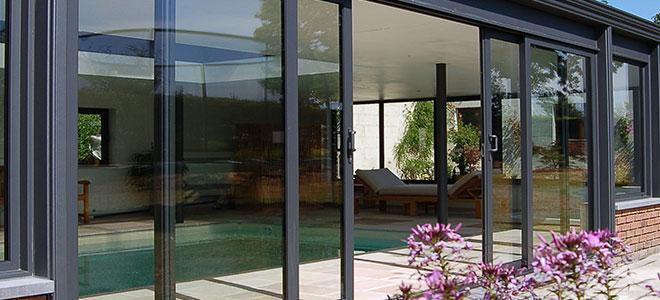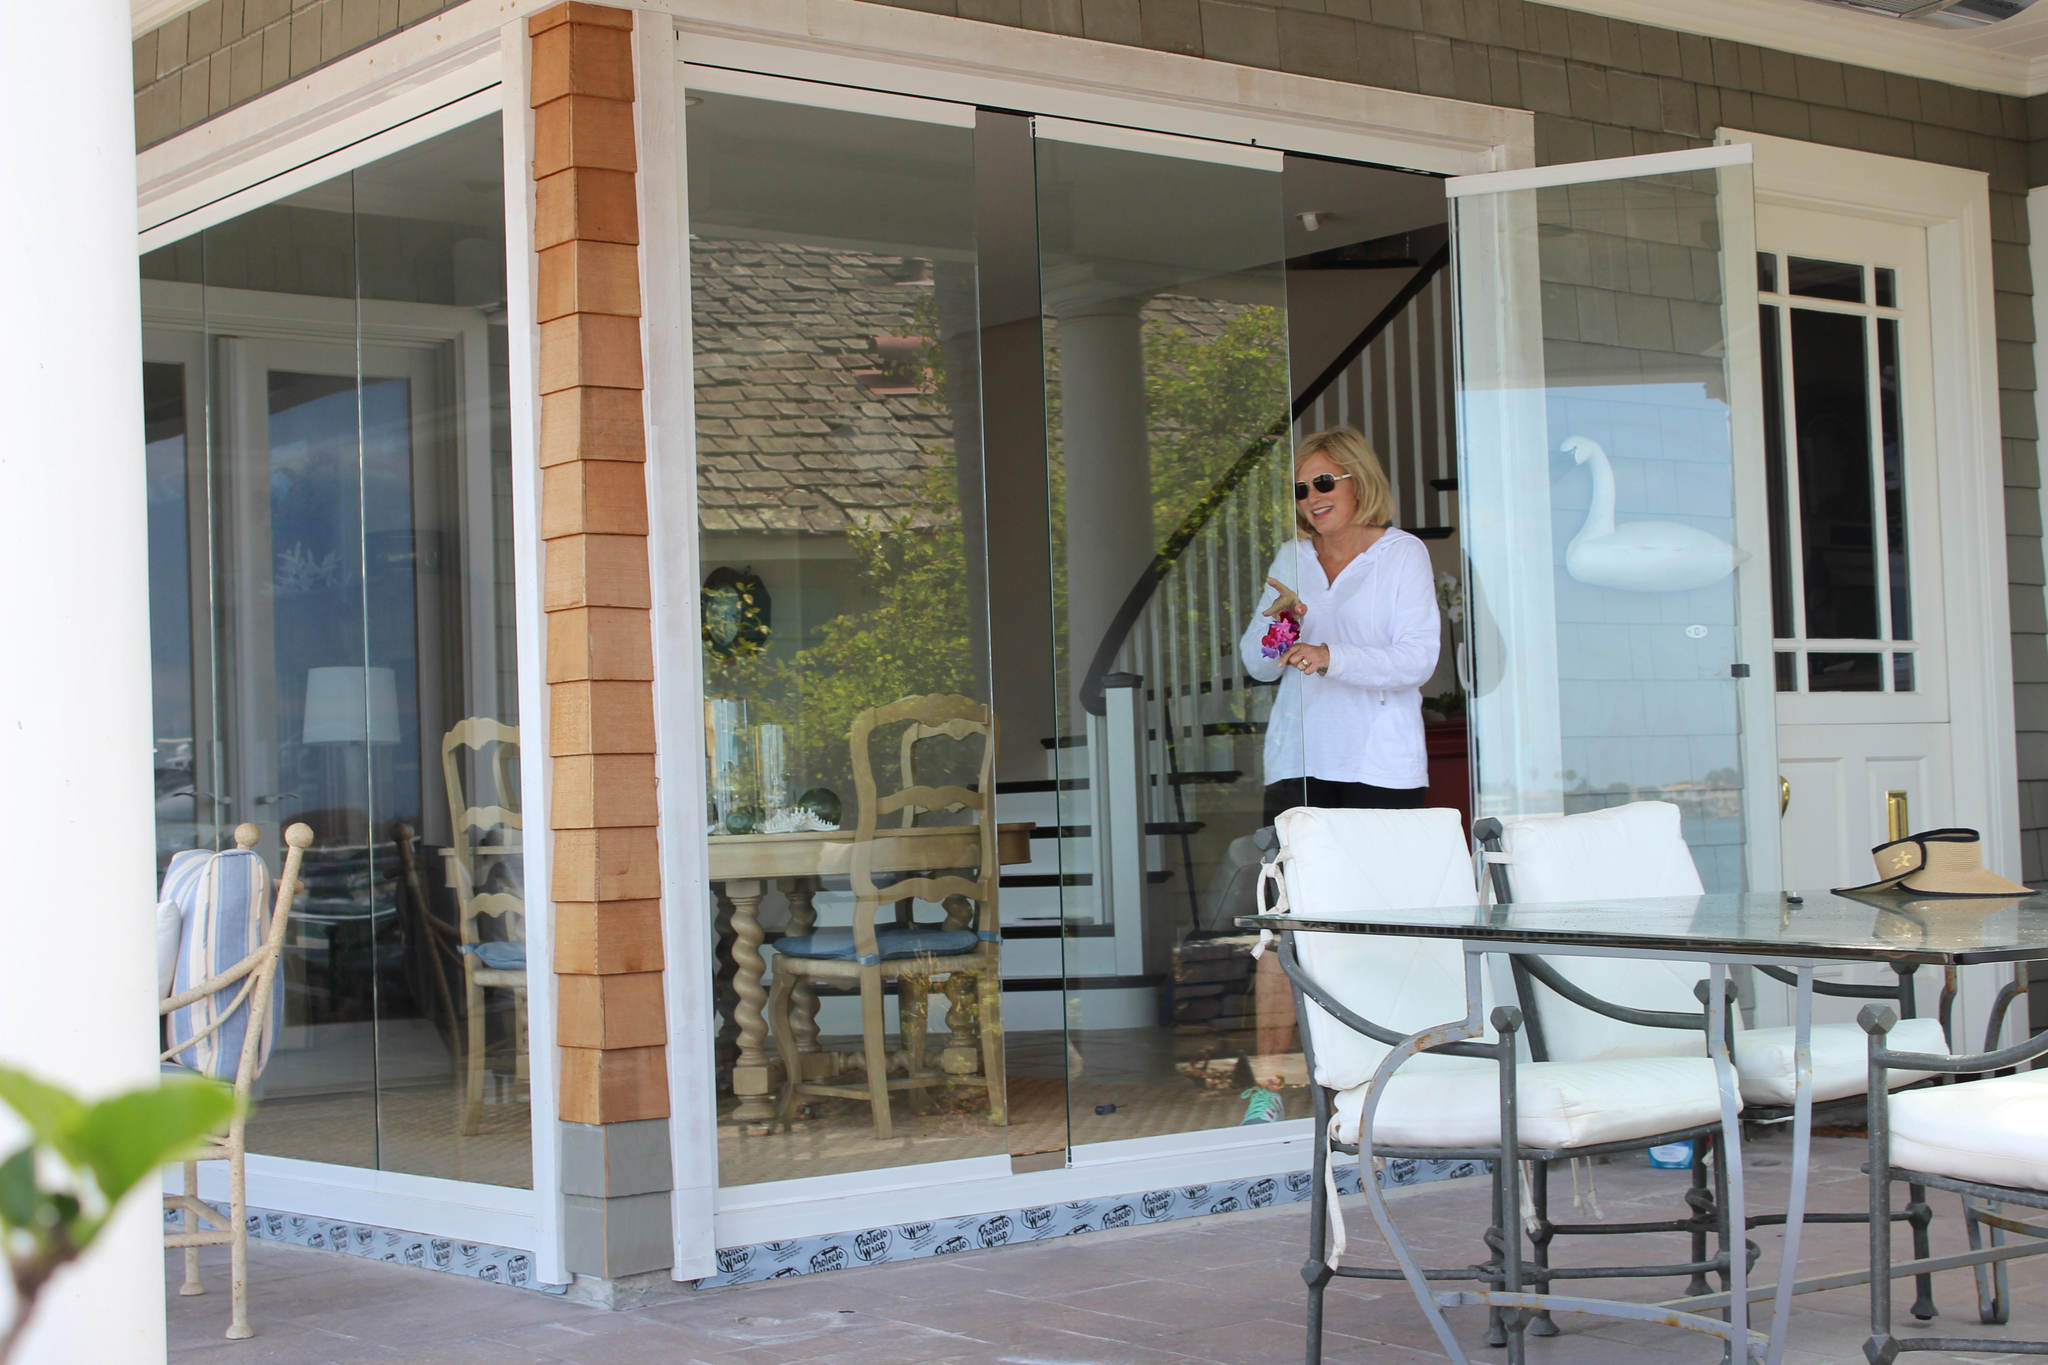The first image is the image on the left, the second image is the image on the right. For the images shown, is this caption "The right image shows columns wth cap tops next to a wall of sliding glass doors and glass windows." true? Answer yes or no. No. The first image is the image on the left, the second image is the image on the right. Analyze the images presented: Is the assertion "Doors are open in both images." valid? Answer yes or no. Yes. 